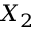<formula> <loc_0><loc_0><loc_500><loc_500>X _ { 2 }</formula> 